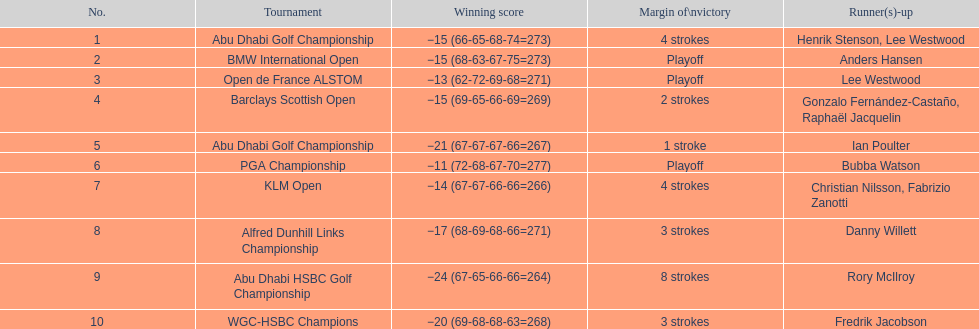Which tournaments did martin kaymer participate in? Abu Dhabi Golf Championship, BMW International Open, Open de France ALSTOM, Barclays Scottish Open, Abu Dhabi Golf Championship, PGA Championship, KLM Open, Alfred Dunhill Links Championship, Abu Dhabi HSBC Golf Championship, WGC-HSBC Champions. How many of these tournaments were won through a playoff? BMW International Open, Open de France ALSTOM, PGA Championship. Which of those tournaments took place in 2010? PGA Championship. Who had to top score next to martin kaymer for that tournament? Bubba Watson. 